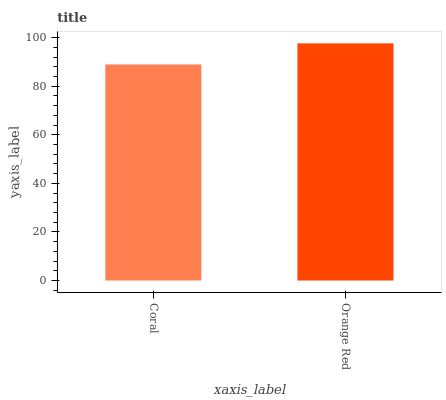Is Coral the minimum?
Answer yes or no. Yes. Is Orange Red the maximum?
Answer yes or no. Yes. Is Orange Red the minimum?
Answer yes or no. No. Is Orange Red greater than Coral?
Answer yes or no. Yes. Is Coral less than Orange Red?
Answer yes or no. Yes. Is Coral greater than Orange Red?
Answer yes or no. No. Is Orange Red less than Coral?
Answer yes or no. No. Is Orange Red the high median?
Answer yes or no. Yes. Is Coral the low median?
Answer yes or no. Yes. Is Coral the high median?
Answer yes or no. No. Is Orange Red the low median?
Answer yes or no. No. 